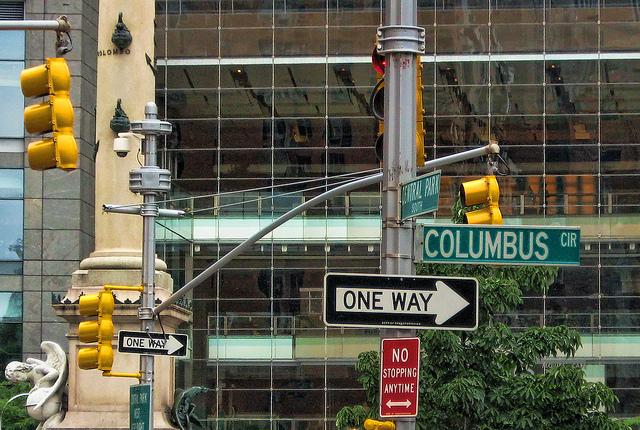Who are the street signs for? drivers 